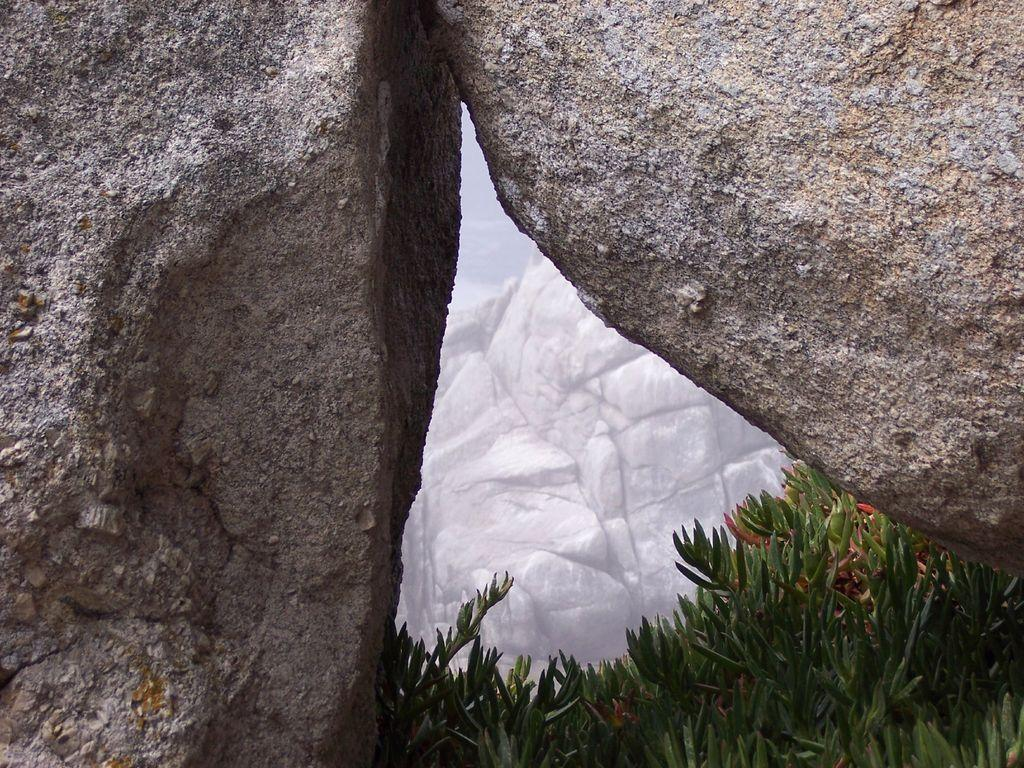What type of living organisms can be seen in the image? Plants can be seen in the image. What other objects are present in the image besides plants? There are rocks in the image. What type of society is depicted in the image? There is no society depicted in the image; it features plants and rocks. Can you tell me how many times the rocks have been crushed in the image? There is no indication of the rocks being crushed in the image. 